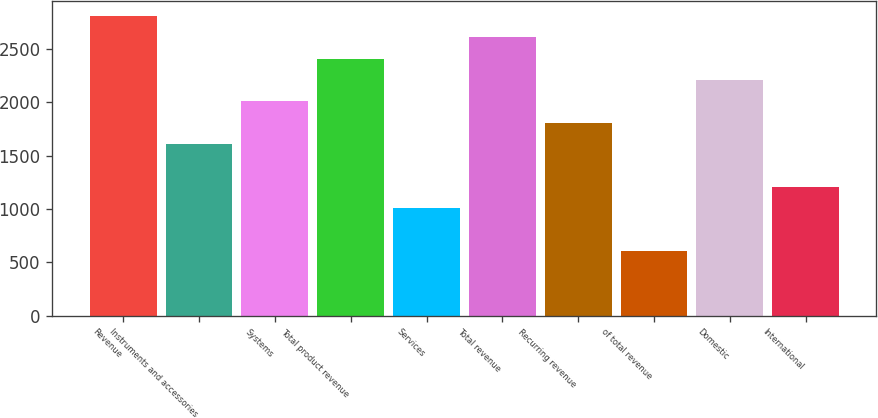<chart> <loc_0><loc_0><loc_500><loc_500><bar_chart><fcel>Revenue<fcel>Instruments and accessories<fcel>Systems<fcel>Total product revenue<fcel>Services<fcel>Total revenue<fcel>Recurring revenue<fcel>of total revenue<fcel>Domestic<fcel>International<nl><fcel>2810.4<fcel>1606.8<fcel>2008<fcel>2409.2<fcel>1005<fcel>2609.8<fcel>1807.4<fcel>603.8<fcel>2208.6<fcel>1205.6<nl></chart> 